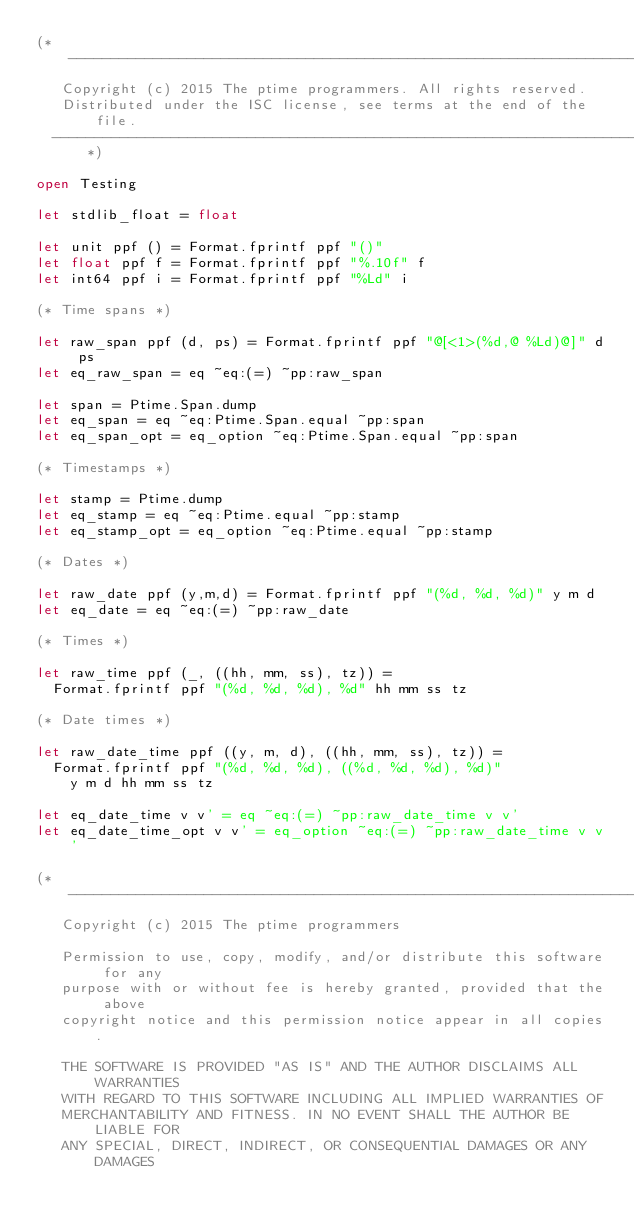<code> <loc_0><loc_0><loc_500><loc_500><_OCaml_>(*---------------------------------------------------------------------------
   Copyright (c) 2015 The ptime programmers. All rights reserved.
   Distributed under the ISC license, see terms at the end of the file.
  ---------------------------------------------------------------------------*)

open Testing

let stdlib_float = float

let unit ppf () = Format.fprintf ppf "()"
let float ppf f = Format.fprintf ppf "%.10f" f
let int64 ppf i = Format.fprintf ppf "%Ld" i

(* Time spans *)

let raw_span ppf (d, ps) = Format.fprintf ppf "@[<1>(%d,@ %Ld)@]" d ps
let eq_raw_span = eq ~eq:(=) ~pp:raw_span

let span = Ptime.Span.dump
let eq_span = eq ~eq:Ptime.Span.equal ~pp:span
let eq_span_opt = eq_option ~eq:Ptime.Span.equal ~pp:span

(* Timestamps *)

let stamp = Ptime.dump
let eq_stamp = eq ~eq:Ptime.equal ~pp:stamp
let eq_stamp_opt = eq_option ~eq:Ptime.equal ~pp:stamp

(* Dates *)

let raw_date ppf (y,m,d) = Format.fprintf ppf "(%d, %d, %d)" y m d
let eq_date = eq ~eq:(=) ~pp:raw_date

(* Times *)

let raw_time ppf (_, ((hh, mm, ss), tz)) =
  Format.fprintf ppf "(%d, %d, %d), %d" hh mm ss tz

(* Date times *)

let raw_date_time ppf ((y, m, d), ((hh, mm, ss), tz)) =
  Format.fprintf ppf "(%d, %d, %d), ((%d, %d, %d), %d)"
    y m d hh mm ss tz

let eq_date_time v v' = eq ~eq:(=) ~pp:raw_date_time v v'
let eq_date_time_opt v v' = eq_option ~eq:(=) ~pp:raw_date_time v v'

(*---------------------------------------------------------------------------
   Copyright (c) 2015 The ptime programmers

   Permission to use, copy, modify, and/or distribute this software for any
   purpose with or without fee is hereby granted, provided that the above
   copyright notice and this permission notice appear in all copies.

   THE SOFTWARE IS PROVIDED "AS IS" AND THE AUTHOR DISCLAIMS ALL WARRANTIES
   WITH REGARD TO THIS SOFTWARE INCLUDING ALL IMPLIED WARRANTIES OF
   MERCHANTABILITY AND FITNESS. IN NO EVENT SHALL THE AUTHOR BE LIABLE FOR
   ANY SPECIAL, DIRECT, INDIRECT, OR CONSEQUENTIAL DAMAGES OR ANY DAMAGES</code> 